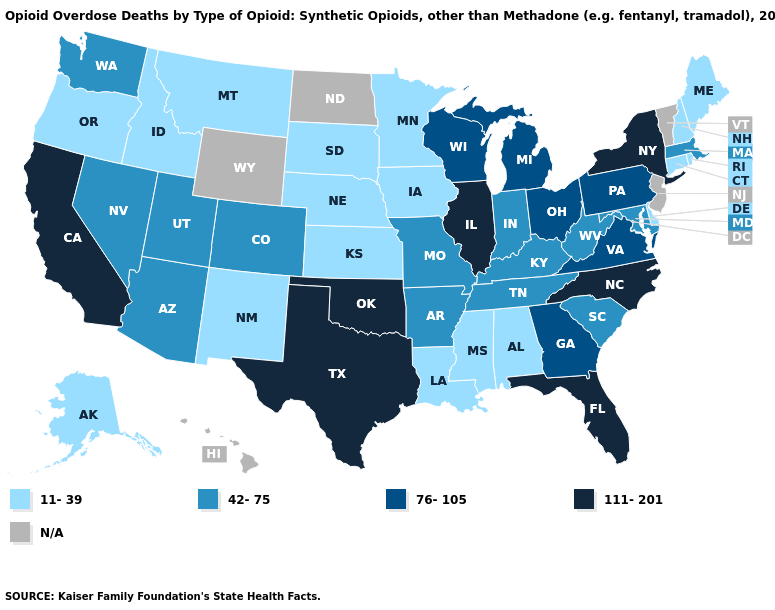What is the value of Wisconsin?
Give a very brief answer. 76-105. What is the lowest value in the MidWest?
Concise answer only. 11-39. What is the lowest value in states that border Arkansas?
Write a very short answer. 11-39. What is the lowest value in the USA?
Keep it brief. 11-39. Does the map have missing data?
Keep it brief. Yes. What is the highest value in the MidWest ?
Write a very short answer. 111-201. Which states hav the highest value in the MidWest?
Be succinct. Illinois. Name the states that have a value in the range 111-201?
Be succinct. California, Florida, Illinois, New York, North Carolina, Oklahoma, Texas. Does Washington have the lowest value in the West?
Answer briefly. No. Among the states that border New Mexico , which have the highest value?
Be succinct. Oklahoma, Texas. Name the states that have a value in the range 111-201?
Write a very short answer. California, Florida, Illinois, New York, North Carolina, Oklahoma, Texas. What is the value of New Jersey?
Concise answer only. N/A. What is the value of Oklahoma?
Write a very short answer. 111-201. What is the lowest value in the Northeast?
Give a very brief answer. 11-39. 